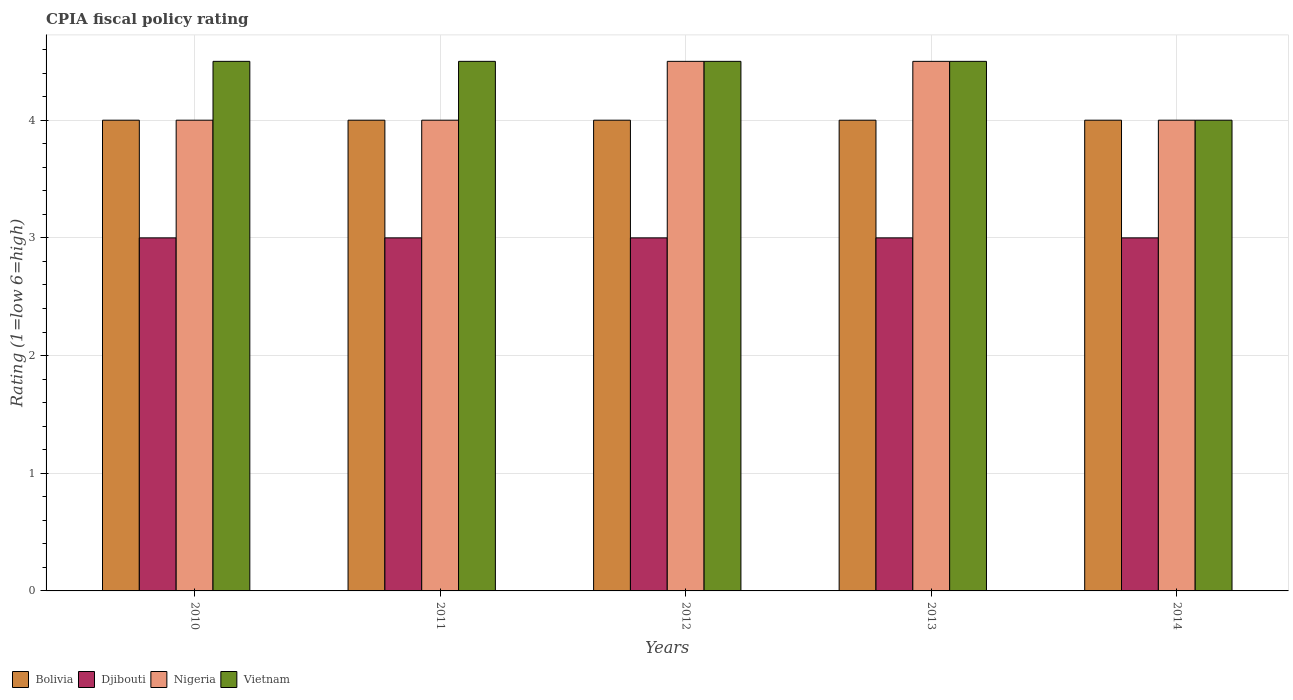How many different coloured bars are there?
Provide a succinct answer. 4. Are the number of bars per tick equal to the number of legend labels?
Your answer should be very brief. Yes. Are the number of bars on each tick of the X-axis equal?
Make the answer very short. Yes. How many bars are there on the 2nd tick from the right?
Offer a very short reply. 4. What is the label of the 5th group of bars from the left?
Your answer should be very brief. 2014. In which year was the CPIA rating in Bolivia maximum?
Keep it short and to the point. 2010. In which year was the CPIA rating in Vietnam minimum?
Your answer should be very brief. 2014. What is the total CPIA rating in Nigeria in the graph?
Your answer should be compact. 21. What is the difference between the CPIA rating in Djibouti in 2012 and that in 2013?
Your response must be concise. 0. What is the difference between the CPIA rating in Vietnam in 2010 and the CPIA rating in Nigeria in 2012?
Ensure brevity in your answer.  0. In the year 2011, what is the difference between the CPIA rating in Nigeria and CPIA rating in Vietnam?
Provide a succinct answer. -0.5. In how many years, is the CPIA rating in Vietnam greater than 2.6?
Ensure brevity in your answer.  5. Is the CPIA rating in Bolivia in 2011 less than that in 2014?
Your answer should be compact. No. What is the difference between the highest and the second highest CPIA rating in Vietnam?
Offer a terse response. 0. What is the difference between the highest and the lowest CPIA rating in Vietnam?
Provide a succinct answer. 0.5. Is the sum of the CPIA rating in Vietnam in 2011 and 2012 greater than the maximum CPIA rating in Nigeria across all years?
Provide a short and direct response. Yes. Is it the case that in every year, the sum of the CPIA rating in Nigeria and CPIA rating in Vietnam is greater than the sum of CPIA rating in Djibouti and CPIA rating in Bolivia?
Your response must be concise. No. What does the 3rd bar from the left in 2013 represents?
Keep it short and to the point. Nigeria. What does the 3rd bar from the right in 2013 represents?
Offer a terse response. Djibouti. Are the values on the major ticks of Y-axis written in scientific E-notation?
Keep it short and to the point. No. Does the graph contain any zero values?
Your answer should be compact. No. Where does the legend appear in the graph?
Give a very brief answer. Bottom left. How are the legend labels stacked?
Give a very brief answer. Horizontal. What is the title of the graph?
Offer a very short reply. CPIA fiscal policy rating. What is the label or title of the Y-axis?
Keep it short and to the point. Rating (1=low 6=high). What is the Rating (1=low 6=high) of Bolivia in 2010?
Make the answer very short. 4. What is the Rating (1=low 6=high) of Djibouti in 2010?
Give a very brief answer. 3. What is the Rating (1=low 6=high) of Nigeria in 2010?
Give a very brief answer. 4. What is the Rating (1=low 6=high) in Vietnam in 2010?
Your answer should be very brief. 4.5. What is the Rating (1=low 6=high) in Bolivia in 2011?
Give a very brief answer. 4. What is the Rating (1=low 6=high) in Vietnam in 2011?
Provide a succinct answer. 4.5. What is the Rating (1=low 6=high) in Djibouti in 2012?
Provide a succinct answer. 3. What is the Rating (1=low 6=high) of Nigeria in 2012?
Provide a succinct answer. 4.5. What is the Rating (1=low 6=high) in Djibouti in 2013?
Offer a very short reply. 3. What is the Rating (1=low 6=high) in Nigeria in 2013?
Provide a short and direct response. 4.5. What is the Rating (1=low 6=high) in Djibouti in 2014?
Keep it short and to the point. 3. Across all years, what is the maximum Rating (1=low 6=high) in Nigeria?
Give a very brief answer. 4.5. Across all years, what is the minimum Rating (1=low 6=high) in Bolivia?
Offer a terse response. 4. What is the total Rating (1=low 6=high) of Djibouti in the graph?
Keep it short and to the point. 15. What is the total Rating (1=low 6=high) of Nigeria in the graph?
Your answer should be compact. 21. What is the total Rating (1=low 6=high) of Vietnam in the graph?
Ensure brevity in your answer.  22. What is the difference between the Rating (1=low 6=high) in Nigeria in 2010 and that in 2011?
Provide a short and direct response. 0. What is the difference between the Rating (1=low 6=high) in Bolivia in 2010 and that in 2012?
Make the answer very short. 0. What is the difference between the Rating (1=low 6=high) of Djibouti in 2010 and that in 2012?
Provide a succinct answer. 0. What is the difference between the Rating (1=low 6=high) in Vietnam in 2010 and that in 2012?
Keep it short and to the point. 0. What is the difference between the Rating (1=low 6=high) in Bolivia in 2010 and that in 2013?
Ensure brevity in your answer.  0. What is the difference between the Rating (1=low 6=high) in Nigeria in 2010 and that in 2013?
Ensure brevity in your answer.  -0.5. What is the difference between the Rating (1=low 6=high) in Bolivia in 2010 and that in 2014?
Your answer should be very brief. 0. What is the difference between the Rating (1=low 6=high) in Djibouti in 2010 and that in 2014?
Provide a short and direct response. 0. What is the difference between the Rating (1=low 6=high) in Bolivia in 2011 and that in 2012?
Give a very brief answer. 0. What is the difference between the Rating (1=low 6=high) in Nigeria in 2011 and that in 2012?
Your answer should be very brief. -0.5. What is the difference between the Rating (1=low 6=high) in Vietnam in 2011 and that in 2012?
Provide a succinct answer. 0. What is the difference between the Rating (1=low 6=high) in Bolivia in 2011 and that in 2013?
Give a very brief answer. 0. What is the difference between the Rating (1=low 6=high) of Djibouti in 2011 and that in 2013?
Your response must be concise. 0. What is the difference between the Rating (1=low 6=high) of Nigeria in 2011 and that in 2013?
Make the answer very short. -0.5. What is the difference between the Rating (1=low 6=high) of Vietnam in 2011 and that in 2013?
Your answer should be compact. 0. What is the difference between the Rating (1=low 6=high) in Vietnam in 2011 and that in 2014?
Provide a succinct answer. 0.5. What is the difference between the Rating (1=low 6=high) of Nigeria in 2012 and that in 2013?
Ensure brevity in your answer.  0. What is the difference between the Rating (1=low 6=high) of Vietnam in 2012 and that in 2013?
Offer a very short reply. 0. What is the difference between the Rating (1=low 6=high) in Bolivia in 2012 and that in 2014?
Make the answer very short. 0. What is the difference between the Rating (1=low 6=high) in Nigeria in 2012 and that in 2014?
Provide a short and direct response. 0.5. What is the difference between the Rating (1=low 6=high) in Djibouti in 2013 and that in 2014?
Your answer should be very brief. 0. What is the difference between the Rating (1=low 6=high) in Nigeria in 2013 and that in 2014?
Keep it short and to the point. 0.5. What is the difference between the Rating (1=low 6=high) of Vietnam in 2013 and that in 2014?
Your answer should be very brief. 0.5. What is the difference between the Rating (1=low 6=high) in Bolivia in 2010 and the Rating (1=low 6=high) in Nigeria in 2011?
Make the answer very short. 0. What is the difference between the Rating (1=low 6=high) in Nigeria in 2010 and the Rating (1=low 6=high) in Vietnam in 2011?
Your response must be concise. -0.5. What is the difference between the Rating (1=low 6=high) of Djibouti in 2010 and the Rating (1=low 6=high) of Nigeria in 2012?
Your answer should be compact. -1.5. What is the difference between the Rating (1=low 6=high) in Djibouti in 2010 and the Rating (1=low 6=high) in Vietnam in 2012?
Keep it short and to the point. -1.5. What is the difference between the Rating (1=low 6=high) of Nigeria in 2010 and the Rating (1=low 6=high) of Vietnam in 2012?
Provide a succinct answer. -0.5. What is the difference between the Rating (1=low 6=high) of Bolivia in 2010 and the Rating (1=low 6=high) of Djibouti in 2013?
Offer a terse response. 1. What is the difference between the Rating (1=low 6=high) in Bolivia in 2010 and the Rating (1=low 6=high) in Nigeria in 2013?
Make the answer very short. -0.5. What is the difference between the Rating (1=low 6=high) of Bolivia in 2010 and the Rating (1=low 6=high) of Vietnam in 2013?
Offer a terse response. -0.5. What is the difference between the Rating (1=low 6=high) of Djibouti in 2010 and the Rating (1=low 6=high) of Nigeria in 2013?
Provide a succinct answer. -1.5. What is the difference between the Rating (1=low 6=high) of Bolivia in 2010 and the Rating (1=low 6=high) of Djibouti in 2014?
Your answer should be very brief. 1. What is the difference between the Rating (1=low 6=high) of Bolivia in 2010 and the Rating (1=low 6=high) of Vietnam in 2014?
Make the answer very short. 0. What is the difference between the Rating (1=low 6=high) in Djibouti in 2010 and the Rating (1=low 6=high) in Vietnam in 2014?
Ensure brevity in your answer.  -1. What is the difference between the Rating (1=low 6=high) in Bolivia in 2011 and the Rating (1=low 6=high) in Djibouti in 2012?
Your response must be concise. 1. What is the difference between the Rating (1=low 6=high) in Djibouti in 2011 and the Rating (1=low 6=high) in Nigeria in 2012?
Provide a short and direct response. -1.5. What is the difference between the Rating (1=low 6=high) of Djibouti in 2011 and the Rating (1=low 6=high) of Vietnam in 2012?
Your response must be concise. -1.5. What is the difference between the Rating (1=low 6=high) of Bolivia in 2011 and the Rating (1=low 6=high) of Djibouti in 2013?
Provide a short and direct response. 1. What is the difference between the Rating (1=low 6=high) of Bolivia in 2011 and the Rating (1=low 6=high) of Vietnam in 2013?
Offer a terse response. -0.5. What is the difference between the Rating (1=low 6=high) of Djibouti in 2011 and the Rating (1=low 6=high) of Nigeria in 2013?
Offer a terse response. -1.5. What is the difference between the Rating (1=low 6=high) in Nigeria in 2011 and the Rating (1=low 6=high) in Vietnam in 2013?
Your answer should be compact. -0.5. What is the difference between the Rating (1=low 6=high) in Bolivia in 2011 and the Rating (1=low 6=high) in Nigeria in 2014?
Give a very brief answer. 0. What is the difference between the Rating (1=low 6=high) in Djibouti in 2011 and the Rating (1=low 6=high) in Vietnam in 2014?
Provide a succinct answer. -1. What is the difference between the Rating (1=low 6=high) in Bolivia in 2012 and the Rating (1=low 6=high) in Djibouti in 2013?
Offer a very short reply. 1. What is the difference between the Rating (1=low 6=high) in Bolivia in 2012 and the Rating (1=low 6=high) in Nigeria in 2013?
Your answer should be compact. -0.5. What is the difference between the Rating (1=low 6=high) of Bolivia in 2012 and the Rating (1=low 6=high) of Nigeria in 2014?
Your response must be concise. 0. What is the difference between the Rating (1=low 6=high) in Bolivia in 2012 and the Rating (1=low 6=high) in Vietnam in 2014?
Your answer should be very brief. 0. What is the difference between the Rating (1=low 6=high) in Djibouti in 2012 and the Rating (1=low 6=high) in Vietnam in 2014?
Your answer should be compact. -1. What is the difference between the Rating (1=low 6=high) of Bolivia in 2013 and the Rating (1=low 6=high) of Djibouti in 2014?
Offer a terse response. 1. What is the difference between the Rating (1=low 6=high) of Djibouti in 2013 and the Rating (1=low 6=high) of Nigeria in 2014?
Ensure brevity in your answer.  -1. What is the difference between the Rating (1=low 6=high) of Nigeria in 2013 and the Rating (1=low 6=high) of Vietnam in 2014?
Provide a succinct answer. 0.5. What is the average Rating (1=low 6=high) of Bolivia per year?
Keep it short and to the point. 4. In the year 2010, what is the difference between the Rating (1=low 6=high) of Bolivia and Rating (1=low 6=high) of Djibouti?
Your answer should be very brief. 1. In the year 2010, what is the difference between the Rating (1=low 6=high) in Bolivia and Rating (1=low 6=high) in Nigeria?
Provide a short and direct response. 0. In the year 2010, what is the difference between the Rating (1=low 6=high) of Djibouti and Rating (1=low 6=high) of Nigeria?
Ensure brevity in your answer.  -1. In the year 2010, what is the difference between the Rating (1=low 6=high) in Djibouti and Rating (1=low 6=high) in Vietnam?
Your response must be concise. -1.5. In the year 2010, what is the difference between the Rating (1=low 6=high) in Nigeria and Rating (1=low 6=high) in Vietnam?
Provide a short and direct response. -0.5. In the year 2011, what is the difference between the Rating (1=low 6=high) in Bolivia and Rating (1=low 6=high) in Vietnam?
Ensure brevity in your answer.  -0.5. In the year 2011, what is the difference between the Rating (1=low 6=high) of Djibouti and Rating (1=low 6=high) of Nigeria?
Provide a short and direct response. -1. In the year 2012, what is the difference between the Rating (1=low 6=high) in Bolivia and Rating (1=low 6=high) in Nigeria?
Provide a succinct answer. -0.5. In the year 2012, what is the difference between the Rating (1=low 6=high) in Djibouti and Rating (1=low 6=high) in Vietnam?
Provide a succinct answer. -1.5. In the year 2012, what is the difference between the Rating (1=low 6=high) in Nigeria and Rating (1=low 6=high) in Vietnam?
Provide a succinct answer. 0. In the year 2013, what is the difference between the Rating (1=low 6=high) in Bolivia and Rating (1=low 6=high) in Djibouti?
Keep it short and to the point. 1. In the year 2013, what is the difference between the Rating (1=low 6=high) in Bolivia and Rating (1=low 6=high) in Nigeria?
Give a very brief answer. -0.5. In the year 2013, what is the difference between the Rating (1=low 6=high) in Bolivia and Rating (1=low 6=high) in Vietnam?
Your answer should be very brief. -0.5. In the year 2013, what is the difference between the Rating (1=low 6=high) of Djibouti and Rating (1=low 6=high) of Nigeria?
Provide a short and direct response. -1.5. In the year 2014, what is the difference between the Rating (1=low 6=high) in Bolivia and Rating (1=low 6=high) in Djibouti?
Provide a short and direct response. 1. What is the ratio of the Rating (1=low 6=high) of Djibouti in 2010 to that in 2011?
Offer a terse response. 1. What is the ratio of the Rating (1=low 6=high) in Bolivia in 2010 to that in 2012?
Your response must be concise. 1. What is the ratio of the Rating (1=low 6=high) in Djibouti in 2010 to that in 2012?
Give a very brief answer. 1. What is the ratio of the Rating (1=low 6=high) in Djibouti in 2010 to that in 2013?
Offer a very short reply. 1. What is the ratio of the Rating (1=low 6=high) of Nigeria in 2010 to that in 2013?
Offer a very short reply. 0.89. What is the ratio of the Rating (1=low 6=high) of Vietnam in 2010 to that in 2013?
Provide a succinct answer. 1. What is the ratio of the Rating (1=low 6=high) of Bolivia in 2010 to that in 2014?
Offer a very short reply. 1. What is the ratio of the Rating (1=low 6=high) of Nigeria in 2010 to that in 2014?
Offer a terse response. 1. What is the ratio of the Rating (1=low 6=high) in Vietnam in 2010 to that in 2014?
Your response must be concise. 1.12. What is the ratio of the Rating (1=low 6=high) of Nigeria in 2011 to that in 2012?
Give a very brief answer. 0.89. What is the ratio of the Rating (1=low 6=high) of Vietnam in 2011 to that in 2013?
Provide a succinct answer. 1. What is the ratio of the Rating (1=low 6=high) in Djibouti in 2011 to that in 2014?
Provide a succinct answer. 1. What is the ratio of the Rating (1=low 6=high) of Nigeria in 2011 to that in 2014?
Make the answer very short. 1. What is the ratio of the Rating (1=low 6=high) in Vietnam in 2011 to that in 2014?
Your response must be concise. 1.12. What is the ratio of the Rating (1=low 6=high) in Djibouti in 2012 to that in 2013?
Provide a succinct answer. 1. What is the ratio of the Rating (1=low 6=high) in Djibouti in 2012 to that in 2014?
Keep it short and to the point. 1. What is the ratio of the Rating (1=low 6=high) in Nigeria in 2012 to that in 2014?
Make the answer very short. 1.12. What is the ratio of the Rating (1=low 6=high) in Bolivia in 2013 to that in 2014?
Your response must be concise. 1. What is the difference between the highest and the second highest Rating (1=low 6=high) in Djibouti?
Your answer should be compact. 0. What is the difference between the highest and the second highest Rating (1=low 6=high) of Nigeria?
Provide a short and direct response. 0. What is the difference between the highest and the second highest Rating (1=low 6=high) in Vietnam?
Give a very brief answer. 0. What is the difference between the highest and the lowest Rating (1=low 6=high) in Nigeria?
Your response must be concise. 0.5. What is the difference between the highest and the lowest Rating (1=low 6=high) of Vietnam?
Provide a succinct answer. 0.5. 